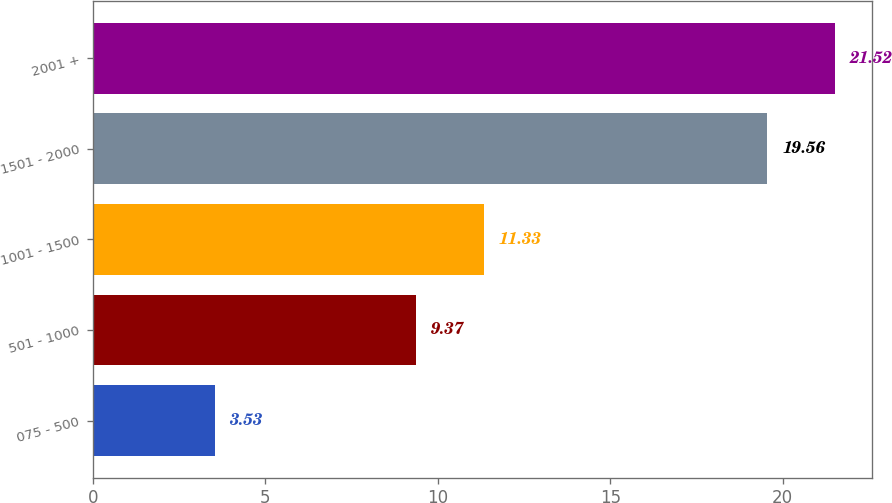<chart> <loc_0><loc_0><loc_500><loc_500><bar_chart><fcel>075 - 500<fcel>501 - 1000<fcel>1001 - 1500<fcel>1501 - 2000<fcel>2001 +<nl><fcel>3.53<fcel>9.37<fcel>11.33<fcel>19.56<fcel>21.52<nl></chart> 